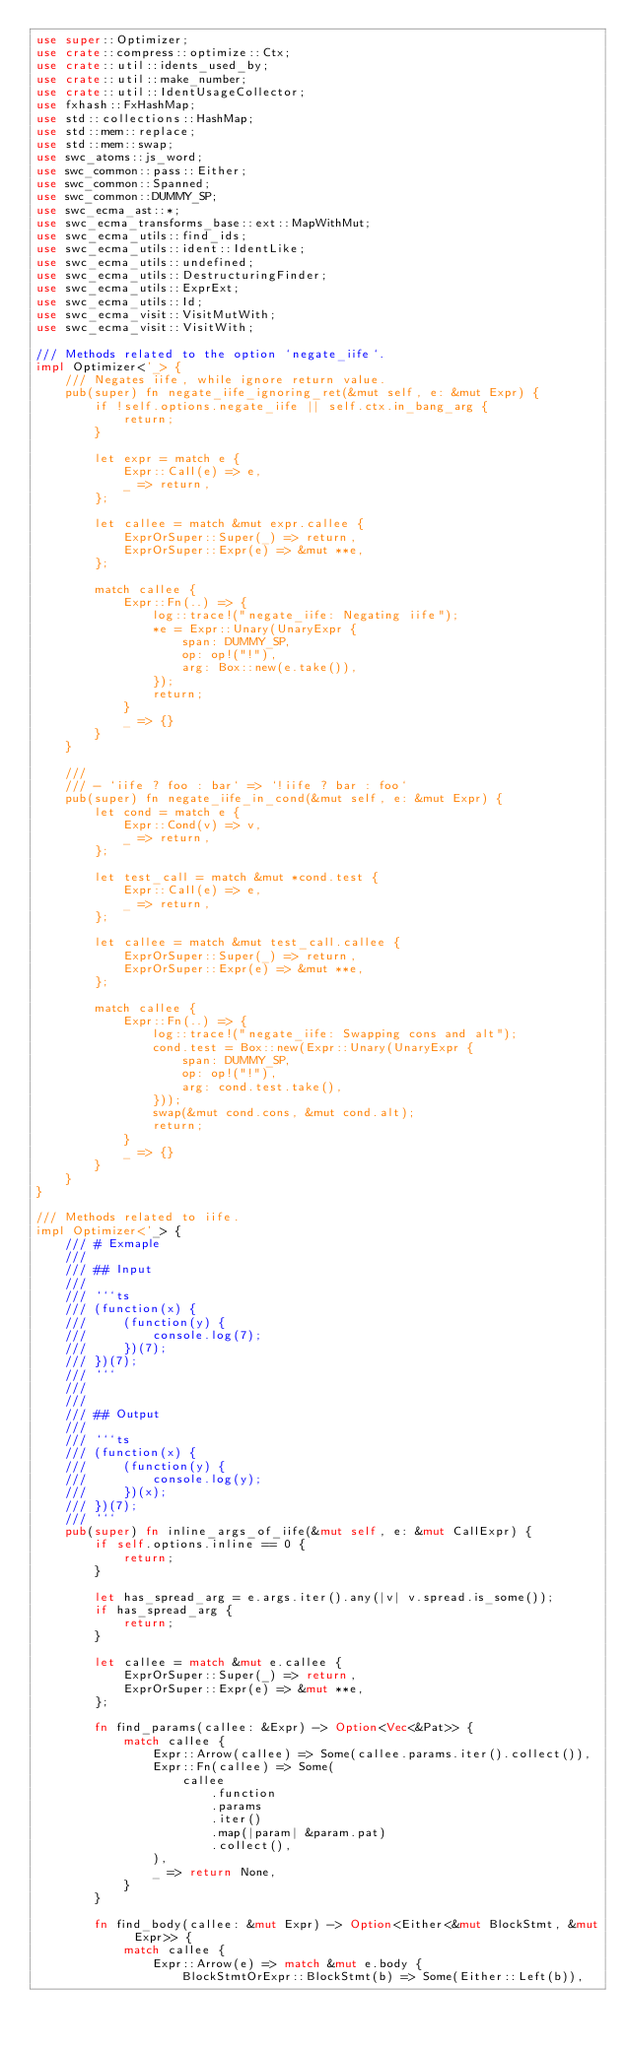<code> <loc_0><loc_0><loc_500><loc_500><_Rust_>use super::Optimizer;
use crate::compress::optimize::Ctx;
use crate::util::idents_used_by;
use crate::util::make_number;
use crate::util::IdentUsageCollector;
use fxhash::FxHashMap;
use std::collections::HashMap;
use std::mem::replace;
use std::mem::swap;
use swc_atoms::js_word;
use swc_common::pass::Either;
use swc_common::Spanned;
use swc_common::DUMMY_SP;
use swc_ecma_ast::*;
use swc_ecma_transforms_base::ext::MapWithMut;
use swc_ecma_utils::find_ids;
use swc_ecma_utils::ident::IdentLike;
use swc_ecma_utils::undefined;
use swc_ecma_utils::DestructuringFinder;
use swc_ecma_utils::ExprExt;
use swc_ecma_utils::Id;
use swc_ecma_visit::VisitMutWith;
use swc_ecma_visit::VisitWith;

/// Methods related to the option `negate_iife`.
impl Optimizer<'_> {
    /// Negates iife, while ignore return value.
    pub(super) fn negate_iife_ignoring_ret(&mut self, e: &mut Expr) {
        if !self.options.negate_iife || self.ctx.in_bang_arg {
            return;
        }

        let expr = match e {
            Expr::Call(e) => e,
            _ => return,
        };

        let callee = match &mut expr.callee {
            ExprOrSuper::Super(_) => return,
            ExprOrSuper::Expr(e) => &mut **e,
        };

        match callee {
            Expr::Fn(..) => {
                log::trace!("negate_iife: Negating iife");
                *e = Expr::Unary(UnaryExpr {
                    span: DUMMY_SP,
                    op: op!("!"),
                    arg: Box::new(e.take()),
                });
                return;
            }
            _ => {}
        }
    }

    ///
    /// - `iife ? foo : bar` => `!iife ? bar : foo`
    pub(super) fn negate_iife_in_cond(&mut self, e: &mut Expr) {
        let cond = match e {
            Expr::Cond(v) => v,
            _ => return,
        };

        let test_call = match &mut *cond.test {
            Expr::Call(e) => e,
            _ => return,
        };

        let callee = match &mut test_call.callee {
            ExprOrSuper::Super(_) => return,
            ExprOrSuper::Expr(e) => &mut **e,
        };

        match callee {
            Expr::Fn(..) => {
                log::trace!("negate_iife: Swapping cons and alt");
                cond.test = Box::new(Expr::Unary(UnaryExpr {
                    span: DUMMY_SP,
                    op: op!("!"),
                    arg: cond.test.take(),
                }));
                swap(&mut cond.cons, &mut cond.alt);
                return;
            }
            _ => {}
        }
    }
}

/// Methods related to iife.
impl Optimizer<'_> {
    /// # Exmaple
    ///
    /// ## Input
    ///
    /// ```ts
    /// (function(x) {
    ///     (function(y) {
    ///         console.log(7);
    ///     })(7);
    /// })(7);
    /// ```
    ///
    ///
    /// ## Output
    ///
    /// ```ts
    /// (function(x) {
    ///     (function(y) {
    ///         console.log(y);
    ///     })(x);
    /// })(7);
    /// ```
    pub(super) fn inline_args_of_iife(&mut self, e: &mut CallExpr) {
        if self.options.inline == 0 {
            return;
        }

        let has_spread_arg = e.args.iter().any(|v| v.spread.is_some());
        if has_spread_arg {
            return;
        }

        let callee = match &mut e.callee {
            ExprOrSuper::Super(_) => return,
            ExprOrSuper::Expr(e) => &mut **e,
        };

        fn find_params(callee: &Expr) -> Option<Vec<&Pat>> {
            match callee {
                Expr::Arrow(callee) => Some(callee.params.iter().collect()),
                Expr::Fn(callee) => Some(
                    callee
                        .function
                        .params
                        .iter()
                        .map(|param| &param.pat)
                        .collect(),
                ),
                _ => return None,
            }
        }

        fn find_body(callee: &mut Expr) -> Option<Either<&mut BlockStmt, &mut Expr>> {
            match callee {
                Expr::Arrow(e) => match &mut e.body {
                    BlockStmtOrExpr::BlockStmt(b) => Some(Either::Left(b)),</code> 